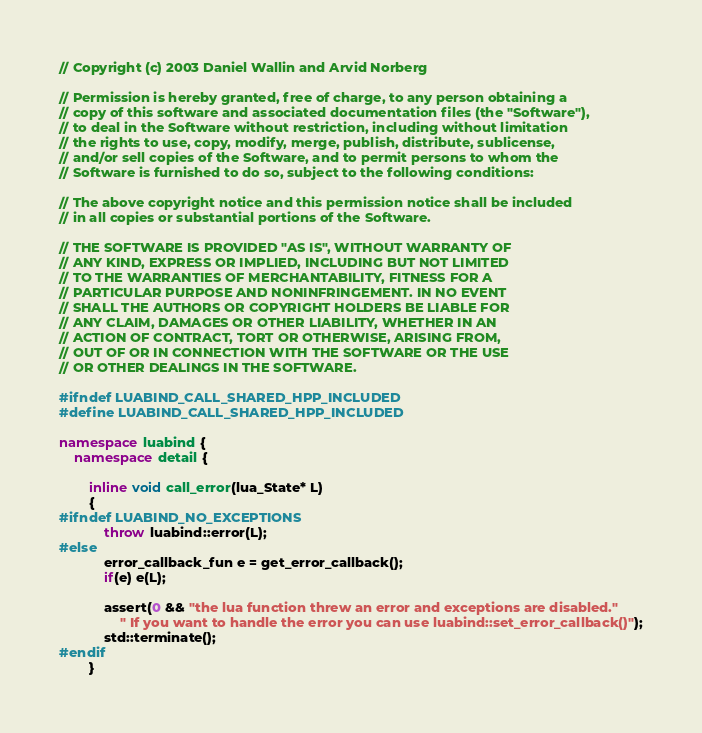Convert code to text. <code><loc_0><loc_0><loc_500><loc_500><_C++_>// Copyright (c) 2003 Daniel Wallin and Arvid Norberg

// Permission is hereby granted, free of charge, to any person obtaining a
// copy of this software and associated documentation files (the "Software"),
// to deal in the Software without restriction, including without limitation
// the rights to use, copy, modify, merge, publish, distribute, sublicense,
// and/or sell copies of the Software, and to permit persons to whom the
// Software is furnished to do so, subject to the following conditions:

// The above copyright notice and this permission notice shall be included
// in all copies or substantial portions of the Software.

// THE SOFTWARE IS PROVIDED "AS IS", WITHOUT WARRANTY OF
// ANY KIND, EXPRESS OR IMPLIED, INCLUDING BUT NOT LIMITED
// TO THE WARRANTIES OF MERCHANTABILITY, FITNESS FOR A
// PARTICULAR PURPOSE AND NONINFRINGEMENT. IN NO EVENT
// SHALL THE AUTHORS OR COPYRIGHT HOLDERS BE LIABLE FOR
// ANY CLAIM, DAMAGES OR OTHER LIABILITY, WHETHER IN AN
// ACTION OF CONTRACT, TORT OR OTHERWISE, ARISING FROM,
// OUT OF OR IN CONNECTION WITH THE SOFTWARE OR THE USE
// OR OTHER DEALINGS IN THE SOFTWARE.

#ifndef LUABIND_CALL_SHARED_HPP_INCLUDED
#define LUABIND_CALL_SHARED_HPP_INCLUDED

namespace luabind {
	namespace detail {

		inline void call_error(lua_State* L)
		{
#ifndef LUABIND_NO_EXCEPTIONS
			throw luabind::error(L);
#else
			error_callback_fun e = get_error_callback();
			if(e) e(L);

			assert(0 && "the lua function threw an error and exceptions are disabled."
				" If you want to handle the error you can use luabind::set_error_callback()");
			std::terminate();
#endif
		}
</code> 